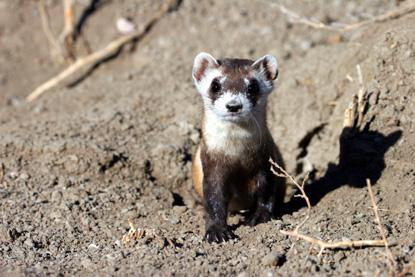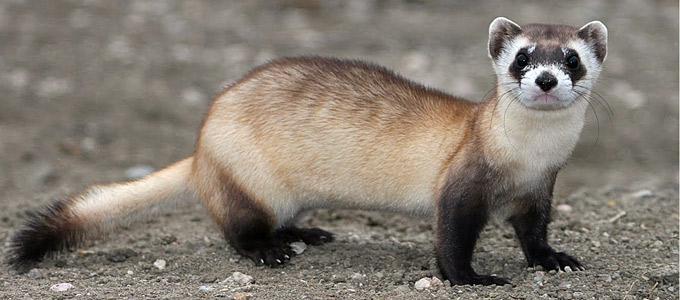The first image is the image on the left, the second image is the image on the right. For the images displayed, is the sentence "The right image contains at least two prairie dogs." factually correct? Answer yes or no. No. The first image is the image on the left, the second image is the image on the right. Given the left and right images, does the statement "There are exactly two ferrets." hold true? Answer yes or no. Yes. 